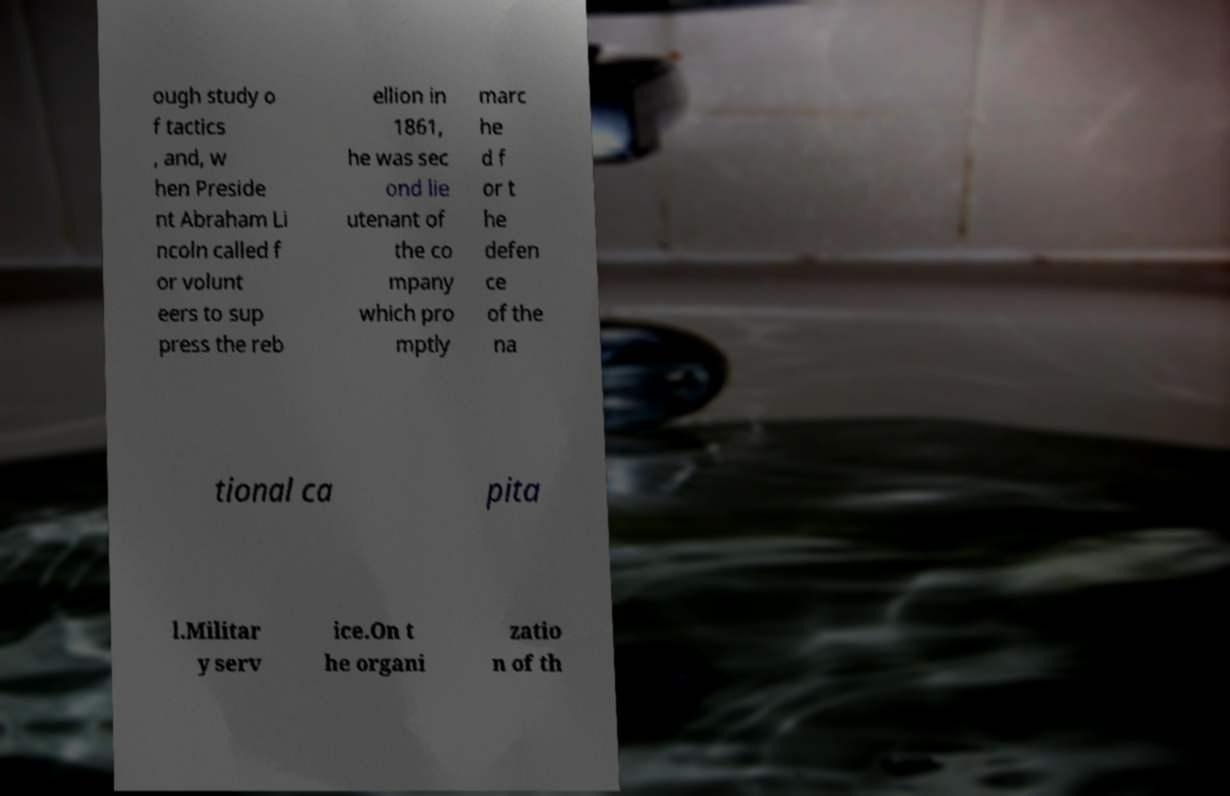Can you read and provide the text displayed in the image?This photo seems to have some interesting text. Can you extract and type it out for me? ough study o f tactics , and, w hen Preside nt Abraham Li ncoln called f or volunt eers to sup press the reb ellion in 1861, he was sec ond lie utenant of the co mpany which pro mptly marc he d f or t he defen ce of the na tional ca pita l.Militar y serv ice.On t he organi zatio n of th 